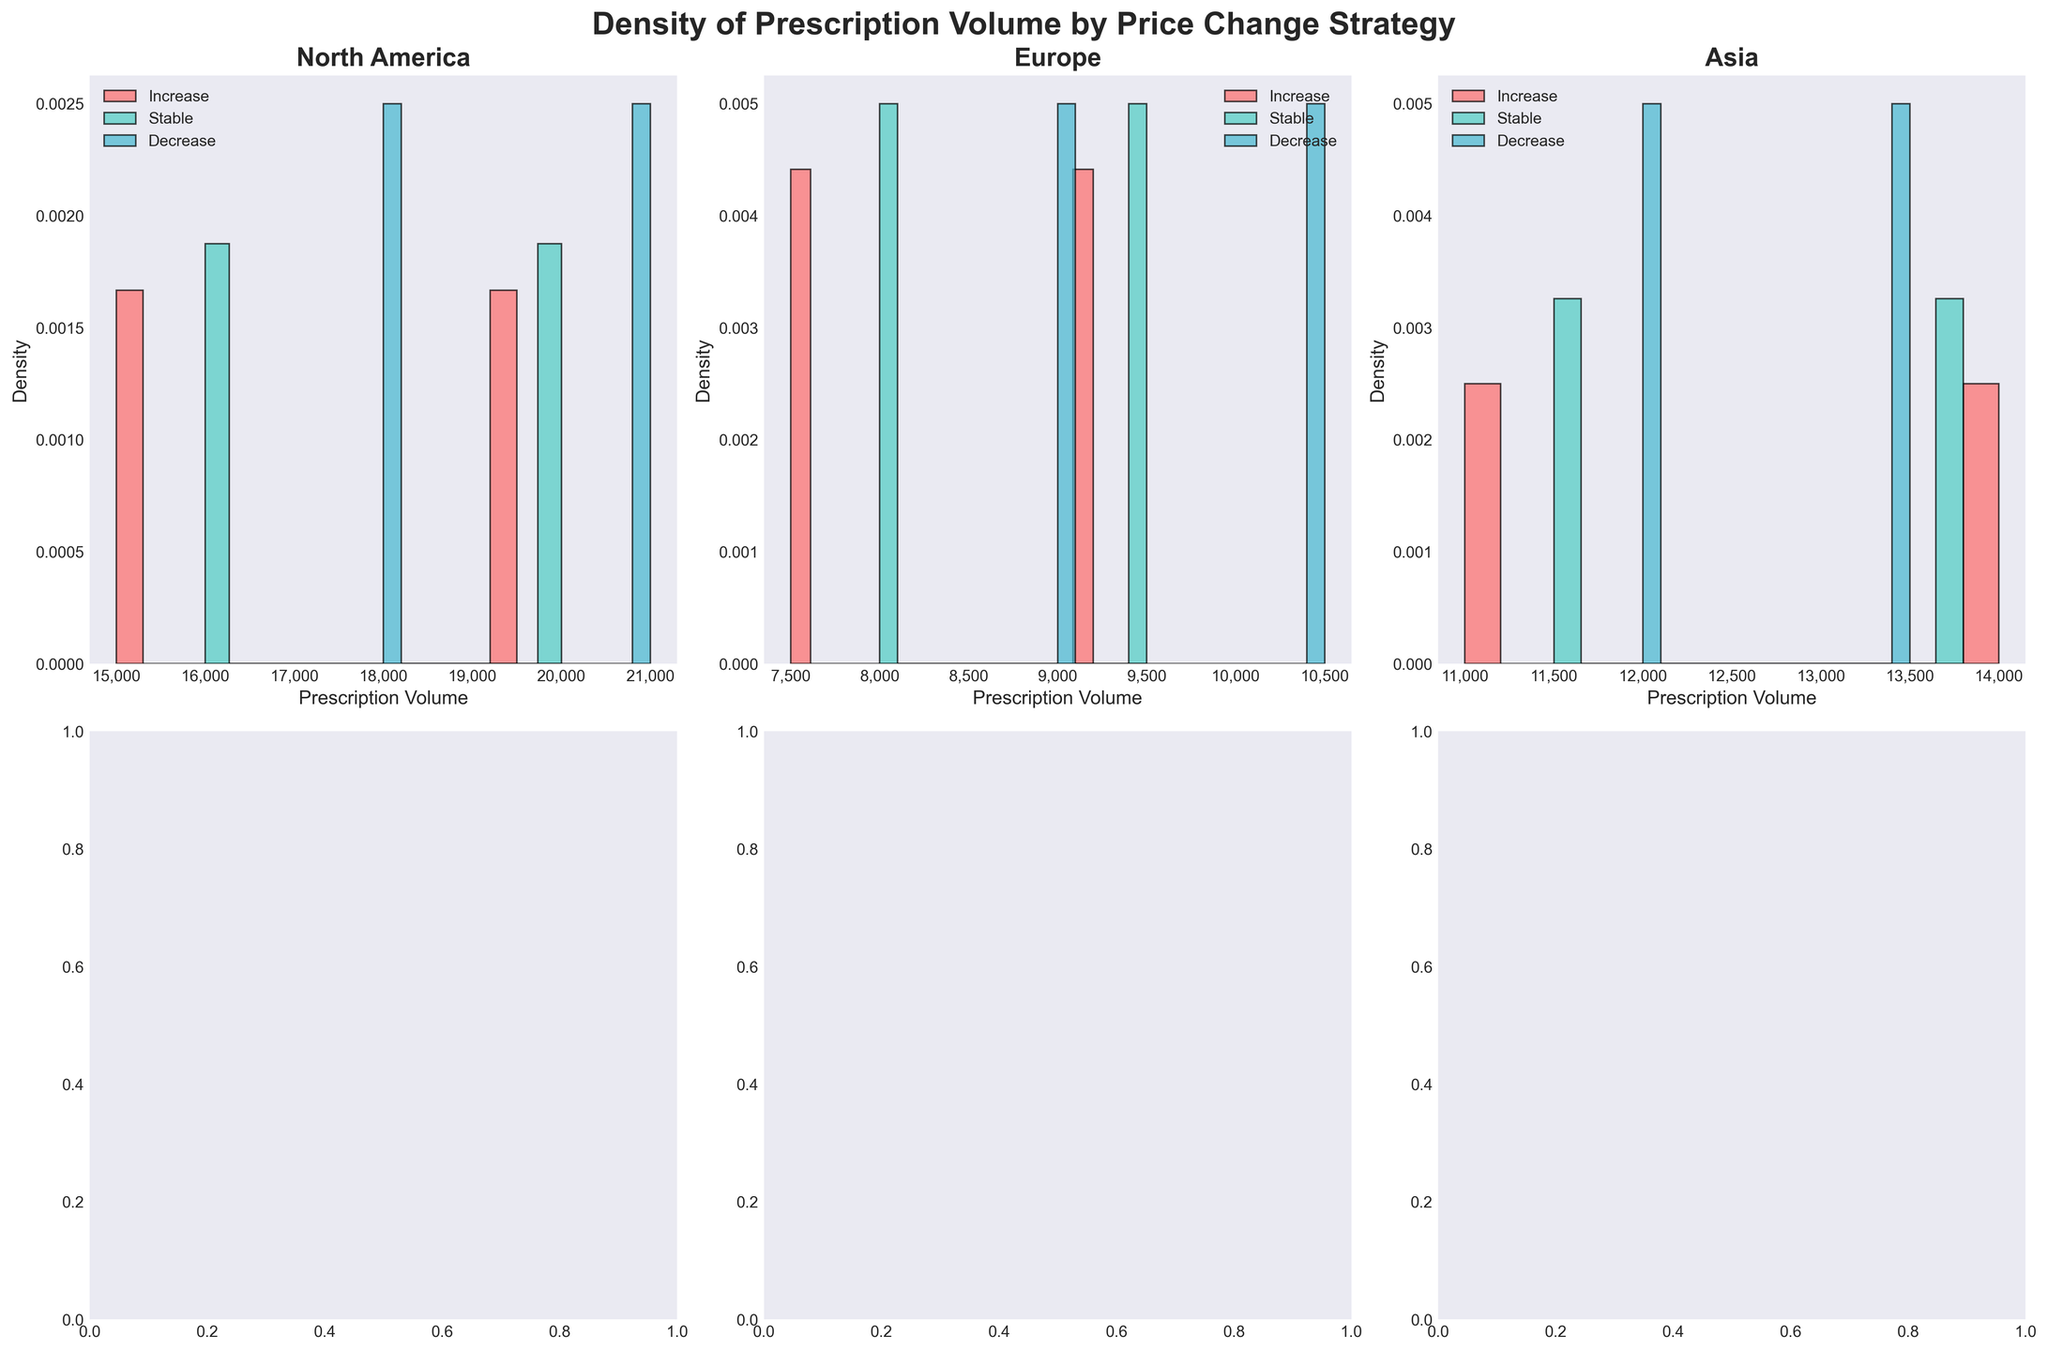What's the title of the figure? The main title of the figure is prominently displayed at the top and reads: "Density of Prescription Volume by Price Change Strategy".
Answer: Density of Prescription Volume by Price Change Strategy Which region has a plot located in the first subplot (top-left corner)? The first subplot is for North America, as indicated by the title in the top-left corner of the figure.
Answer: North America How is the density plot for decreasing prices in Europe depicted? The density plot for decreasing prices in Europe is shown with bars in one of the plots labeled "Europe." The color of the bars associated with decreasing prices is distinct.
Answer: It's in light blue color What is the scale unit of the x-axis in these subplots? By looking at the x-axis of each subplot, it's evident that the unit is "Prescription Volume". Each axis has this label below it.
Answer: Prescription Volume Comparing North America and Asia, which region shows a higher density for volume when prices are stable? First, locate the Stable price strategy in both North America and Asia subplots. Compare the height of the bars; the region with taller bars has a higher density.
Answer: North America Does the subplot for Asia display higher prescription volumes in the density plot when prices increase or when prices decrease? In the Asia subplot, examine the histograms for both price increase and decrease. The strategy with a taller highest bar in the volume range represents higher prescription volumes.
Answer: Increase Which subplot has the most uniform density distribution? Uniformity can be determined by examining which subplot's histogram bars have the least variation in height.
Answer: Europe What's the average volume of prescriptions in the regions shown, based on the visible density distributions? To estimate, examine the central tendencies of each visible density plot across the three subplots to infer an average volume. Summarize the mid-point values across North America's, Europe's, and Asia's distributions.
Answer: Approximately 14000 Which price change strategy appears to be the least frequent across all regions? Determine this by noting the number of representations of each price strategy (increase, stable, decrease) across all subplots and finding the least common one.
Answer: Decrease 